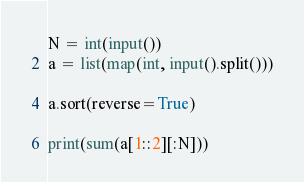Convert code to text. <code><loc_0><loc_0><loc_500><loc_500><_Python_>N = int(input())
a = list(map(int, input().split()))

a.sort(reverse=True)

print(sum(a[1::2][:N]))</code> 